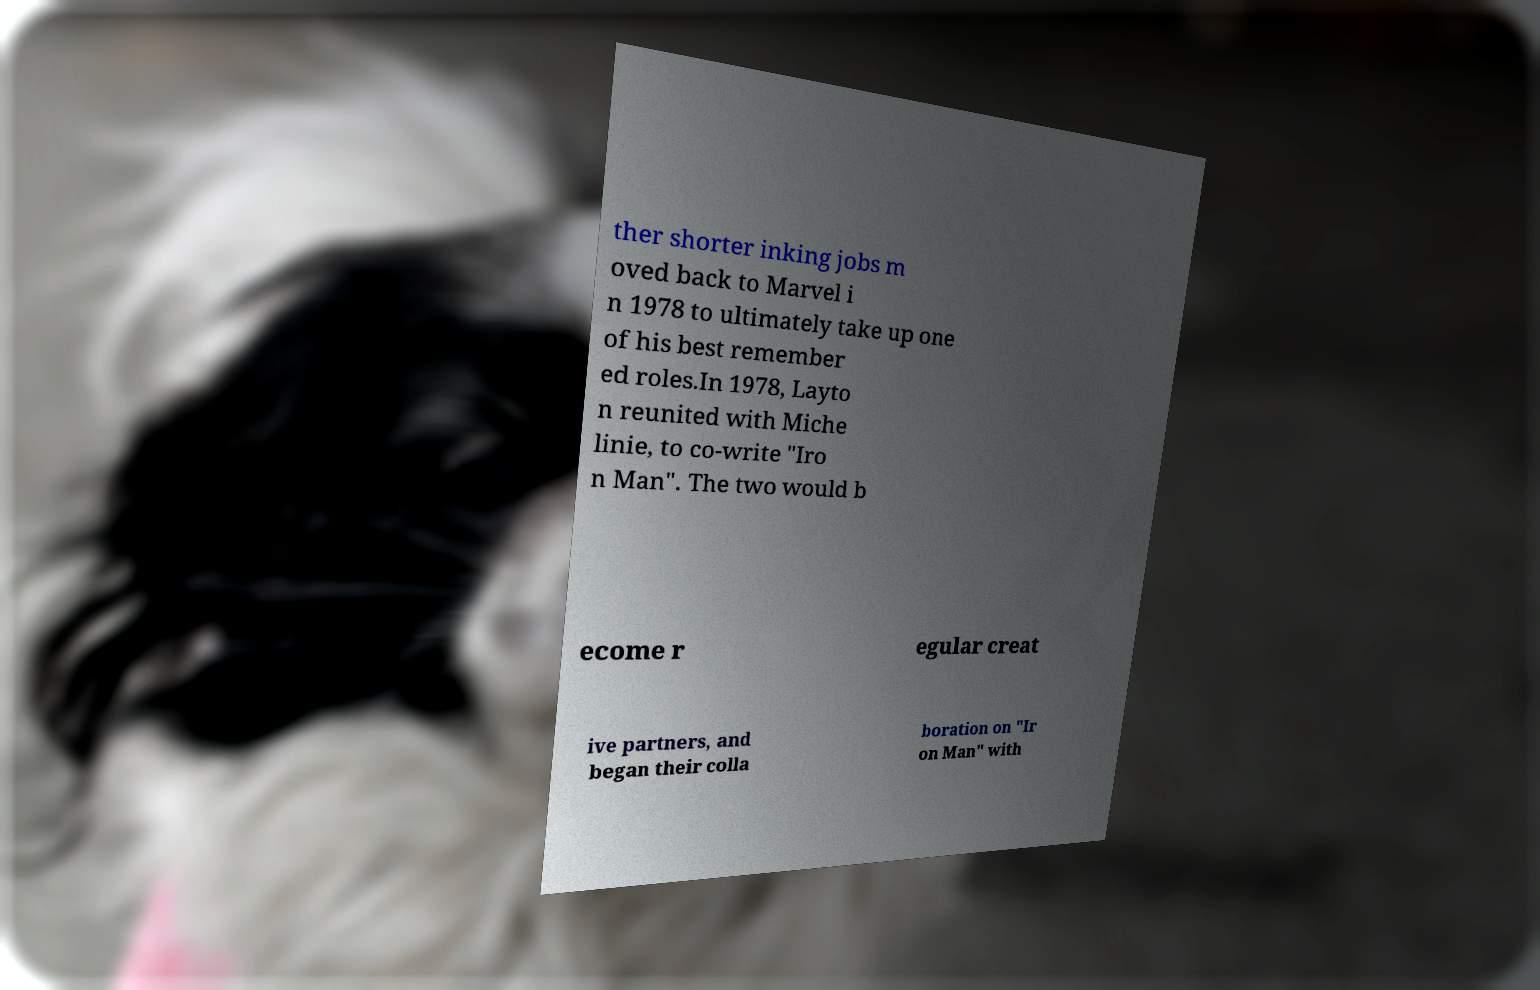I need the written content from this picture converted into text. Can you do that? ther shorter inking jobs m oved back to Marvel i n 1978 to ultimately take up one of his best remember ed roles.In 1978, Layto n reunited with Miche linie, to co-write "Iro n Man". The two would b ecome r egular creat ive partners, and began their colla boration on "Ir on Man" with 